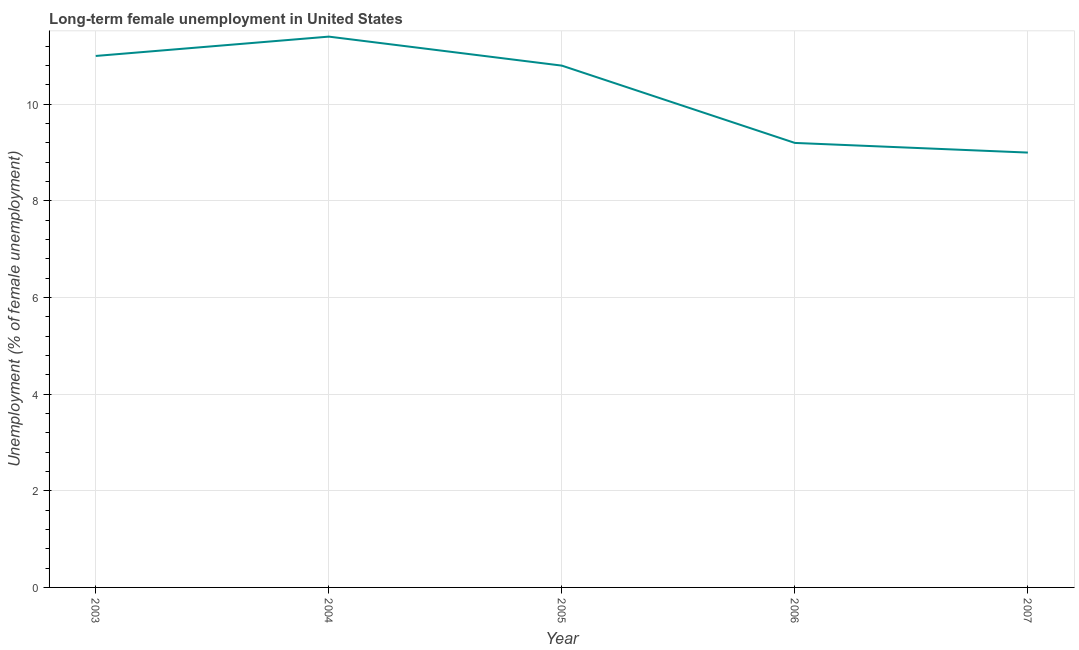What is the long-term female unemployment in 2005?
Your answer should be very brief. 10.8. Across all years, what is the maximum long-term female unemployment?
Ensure brevity in your answer.  11.4. Across all years, what is the minimum long-term female unemployment?
Make the answer very short. 9. In which year was the long-term female unemployment minimum?
Offer a very short reply. 2007. What is the sum of the long-term female unemployment?
Offer a terse response. 51.4. What is the difference between the long-term female unemployment in 2004 and 2007?
Make the answer very short. 2.4. What is the average long-term female unemployment per year?
Your response must be concise. 10.28. What is the median long-term female unemployment?
Provide a short and direct response. 10.8. What is the ratio of the long-term female unemployment in 2003 to that in 2005?
Your answer should be very brief. 1.02. Is the difference between the long-term female unemployment in 2004 and 2005 greater than the difference between any two years?
Offer a very short reply. No. What is the difference between the highest and the second highest long-term female unemployment?
Your response must be concise. 0.4. What is the difference between the highest and the lowest long-term female unemployment?
Your answer should be compact. 2.4. How many lines are there?
Your answer should be compact. 1. How many years are there in the graph?
Offer a terse response. 5. What is the difference between two consecutive major ticks on the Y-axis?
Provide a succinct answer. 2. What is the title of the graph?
Offer a very short reply. Long-term female unemployment in United States. What is the label or title of the Y-axis?
Provide a succinct answer. Unemployment (% of female unemployment). What is the Unemployment (% of female unemployment) of 2003?
Give a very brief answer. 11. What is the Unemployment (% of female unemployment) of 2004?
Offer a terse response. 11.4. What is the Unemployment (% of female unemployment) of 2005?
Your response must be concise. 10.8. What is the Unemployment (% of female unemployment) of 2006?
Your response must be concise. 9.2. What is the difference between the Unemployment (% of female unemployment) in 2003 and 2004?
Offer a terse response. -0.4. What is the difference between the Unemployment (% of female unemployment) in 2003 and 2006?
Provide a short and direct response. 1.8. What is the difference between the Unemployment (% of female unemployment) in 2004 and 2005?
Your response must be concise. 0.6. What is the ratio of the Unemployment (% of female unemployment) in 2003 to that in 2006?
Your response must be concise. 1.2. What is the ratio of the Unemployment (% of female unemployment) in 2003 to that in 2007?
Provide a succinct answer. 1.22. What is the ratio of the Unemployment (% of female unemployment) in 2004 to that in 2005?
Provide a succinct answer. 1.06. What is the ratio of the Unemployment (% of female unemployment) in 2004 to that in 2006?
Provide a succinct answer. 1.24. What is the ratio of the Unemployment (% of female unemployment) in 2004 to that in 2007?
Provide a succinct answer. 1.27. What is the ratio of the Unemployment (% of female unemployment) in 2005 to that in 2006?
Make the answer very short. 1.17. What is the ratio of the Unemployment (% of female unemployment) in 2006 to that in 2007?
Ensure brevity in your answer.  1.02. 